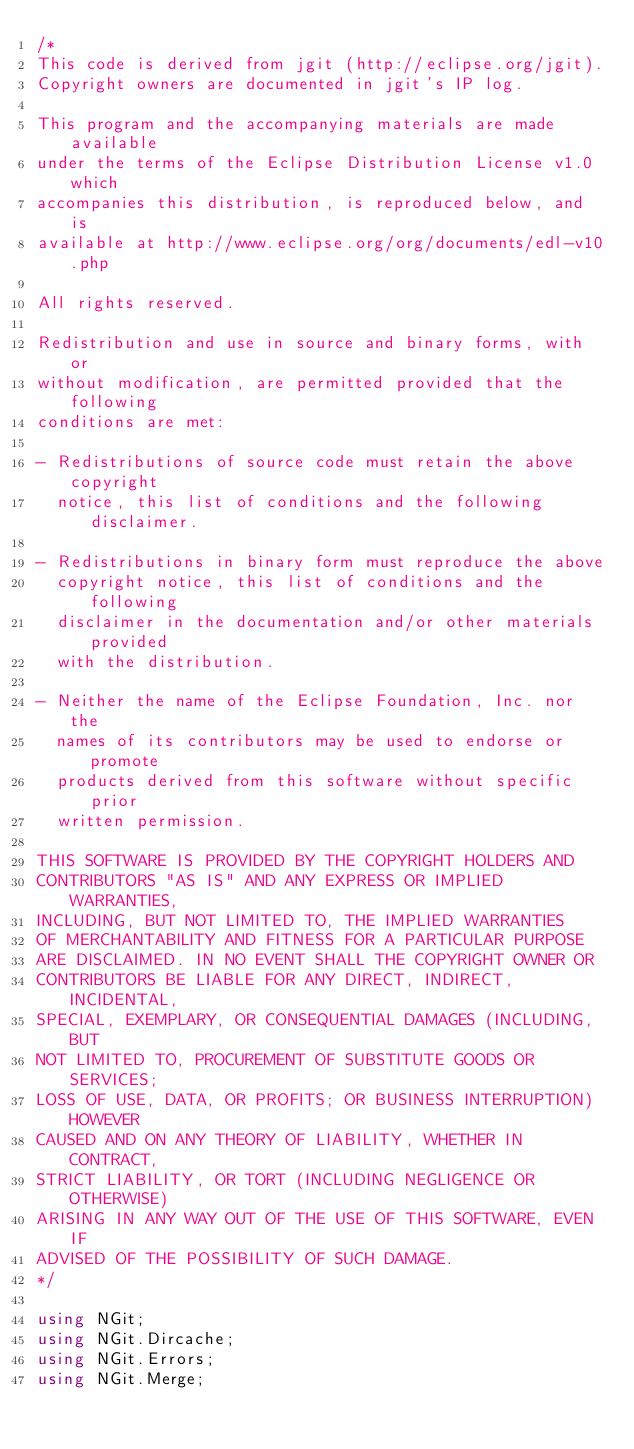Convert code to text. <code><loc_0><loc_0><loc_500><loc_500><_C#_>/*
This code is derived from jgit (http://eclipse.org/jgit).
Copyright owners are documented in jgit's IP log.

This program and the accompanying materials are made available
under the terms of the Eclipse Distribution License v1.0 which
accompanies this distribution, is reproduced below, and is
available at http://www.eclipse.org/org/documents/edl-v10.php

All rights reserved.

Redistribution and use in source and binary forms, with or
without modification, are permitted provided that the following
conditions are met:

- Redistributions of source code must retain the above copyright
  notice, this list of conditions and the following disclaimer.

- Redistributions in binary form must reproduce the above
  copyright notice, this list of conditions and the following
  disclaimer in the documentation and/or other materials provided
  with the distribution.

- Neither the name of the Eclipse Foundation, Inc. nor the
  names of its contributors may be used to endorse or promote
  products derived from this software without specific prior
  written permission.

THIS SOFTWARE IS PROVIDED BY THE COPYRIGHT HOLDERS AND
CONTRIBUTORS "AS IS" AND ANY EXPRESS OR IMPLIED WARRANTIES,
INCLUDING, BUT NOT LIMITED TO, THE IMPLIED WARRANTIES
OF MERCHANTABILITY AND FITNESS FOR A PARTICULAR PURPOSE
ARE DISCLAIMED. IN NO EVENT SHALL THE COPYRIGHT OWNER OR
CONTRIBUTORS BE LIABLE FOR ANY DIRECT, INDIRECT, INCIDENTAL,
SPECIAL, EXEMPLARY, OR CONSEQUENTIAL DAMAGES (INCLUDING, BUT
NOT LIMITED TO, PROCUREMENT OF SUBSTITUTE GOODS OR SERVICES;
LOSS OF USE, DATA, OR PROFITS; OR BUSINESS INTERRUPTION) HOWEVER
CAUSED AND ON ANY THEORY OF LIABILITY, WHETHER IN CONTRACT,
STRICT LIABILITY, OR TORT (INCLUDING NEGLIGENCE OR OTHERWISE)
ARISING IN ANY WAY OUT OF THE USE OF THIS SOFTWARE, EVEN IF
ADVISED OF THE POSSIBILITY OF SUCH DAMAGE.
*/

using NGit;
using NGit.Dircache;
using NGit.Errors;
using NGit.Merge;</code> 